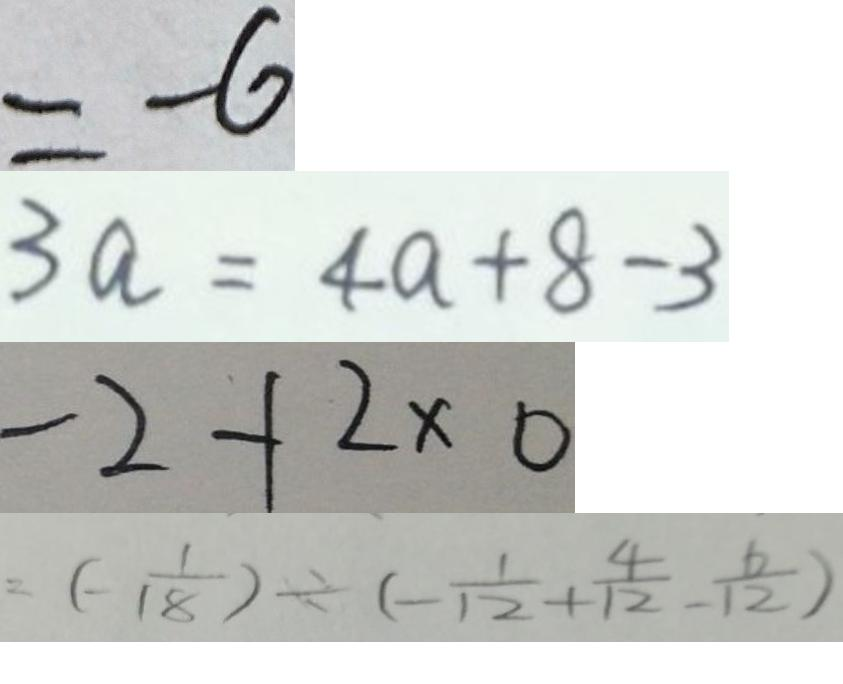<formula> <loc_0><loc_0><loc_500><loc_500>= - 6 
 3 a = 4 a + 8 - 3 
 - 2 + 2 \times 0 
 = ( - \frac { 1 } { 1 8 } ) \div ( - \frac { 1 } { 1 2 } + \frac { 4 } { 1 2 } - \frac { 6 } { 1 2 } )</formula> 